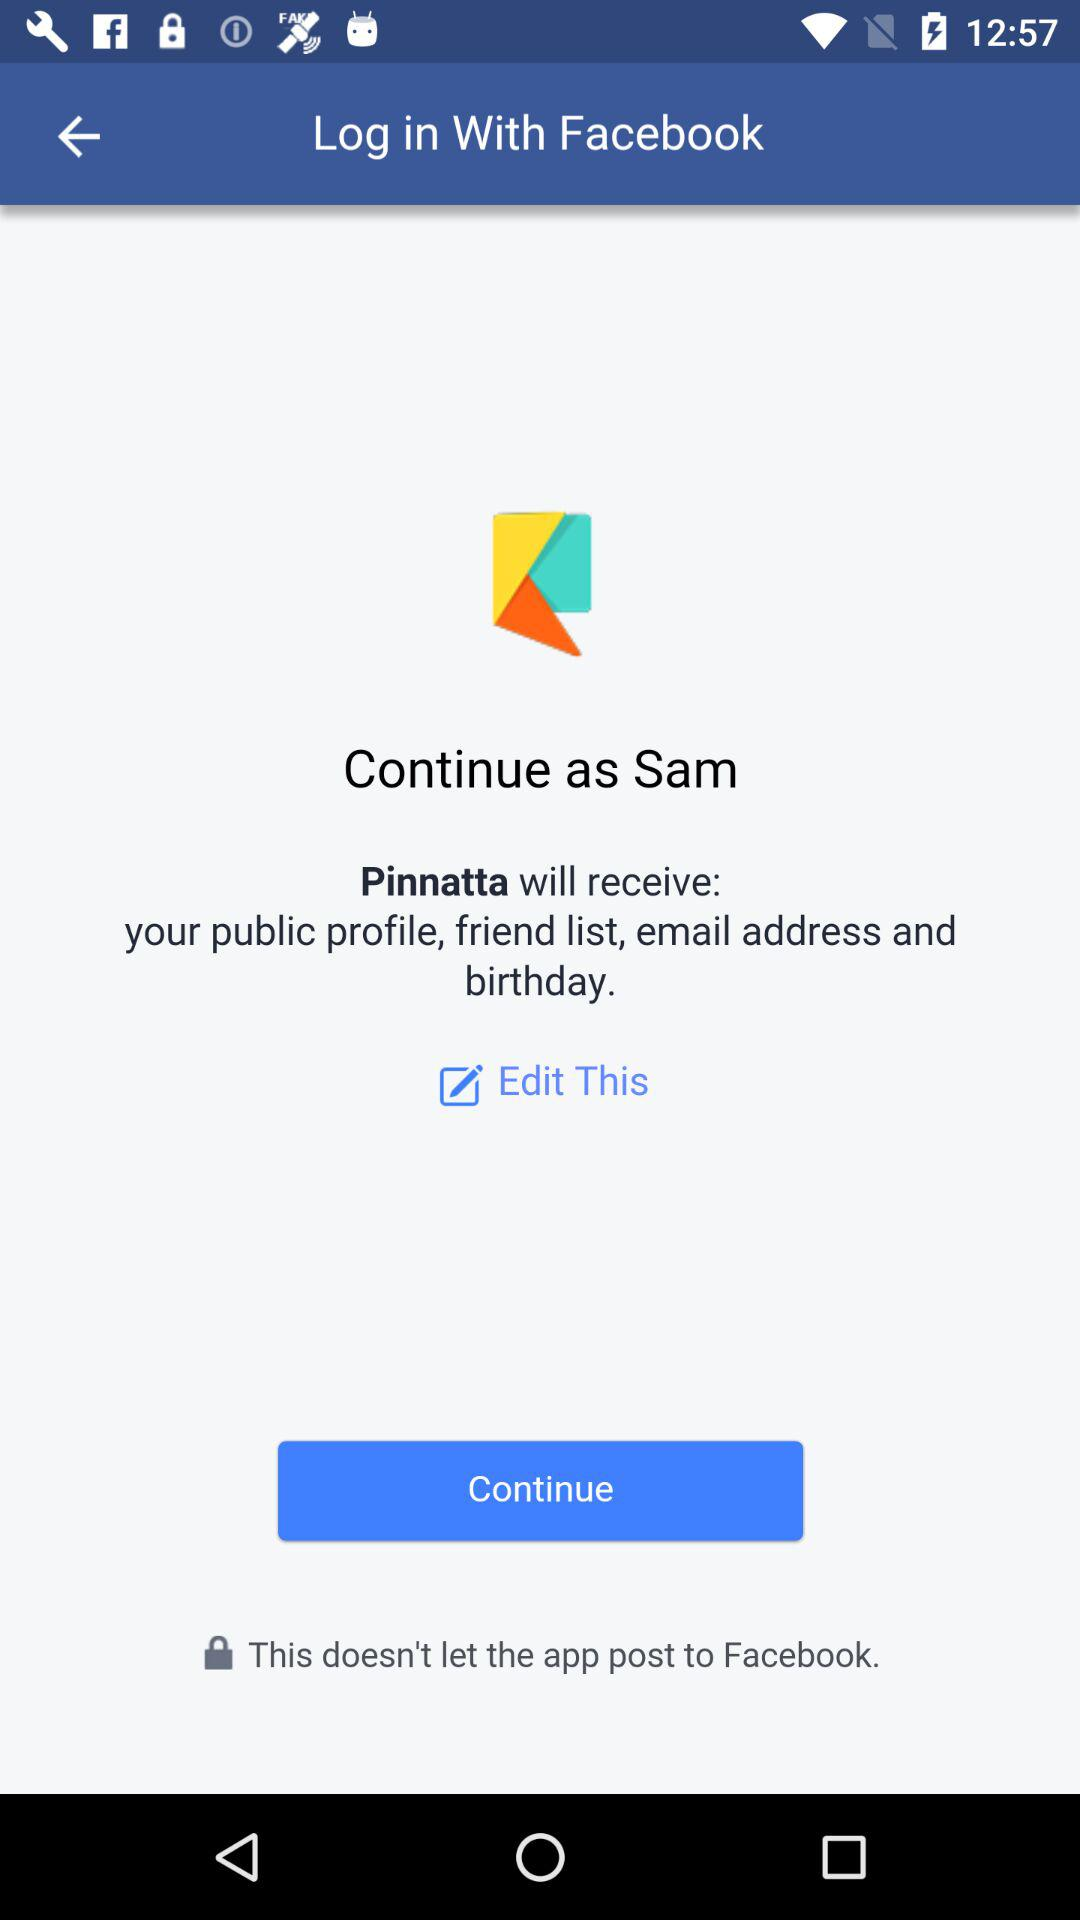What is the name of the user? The name of the user is Sam. 